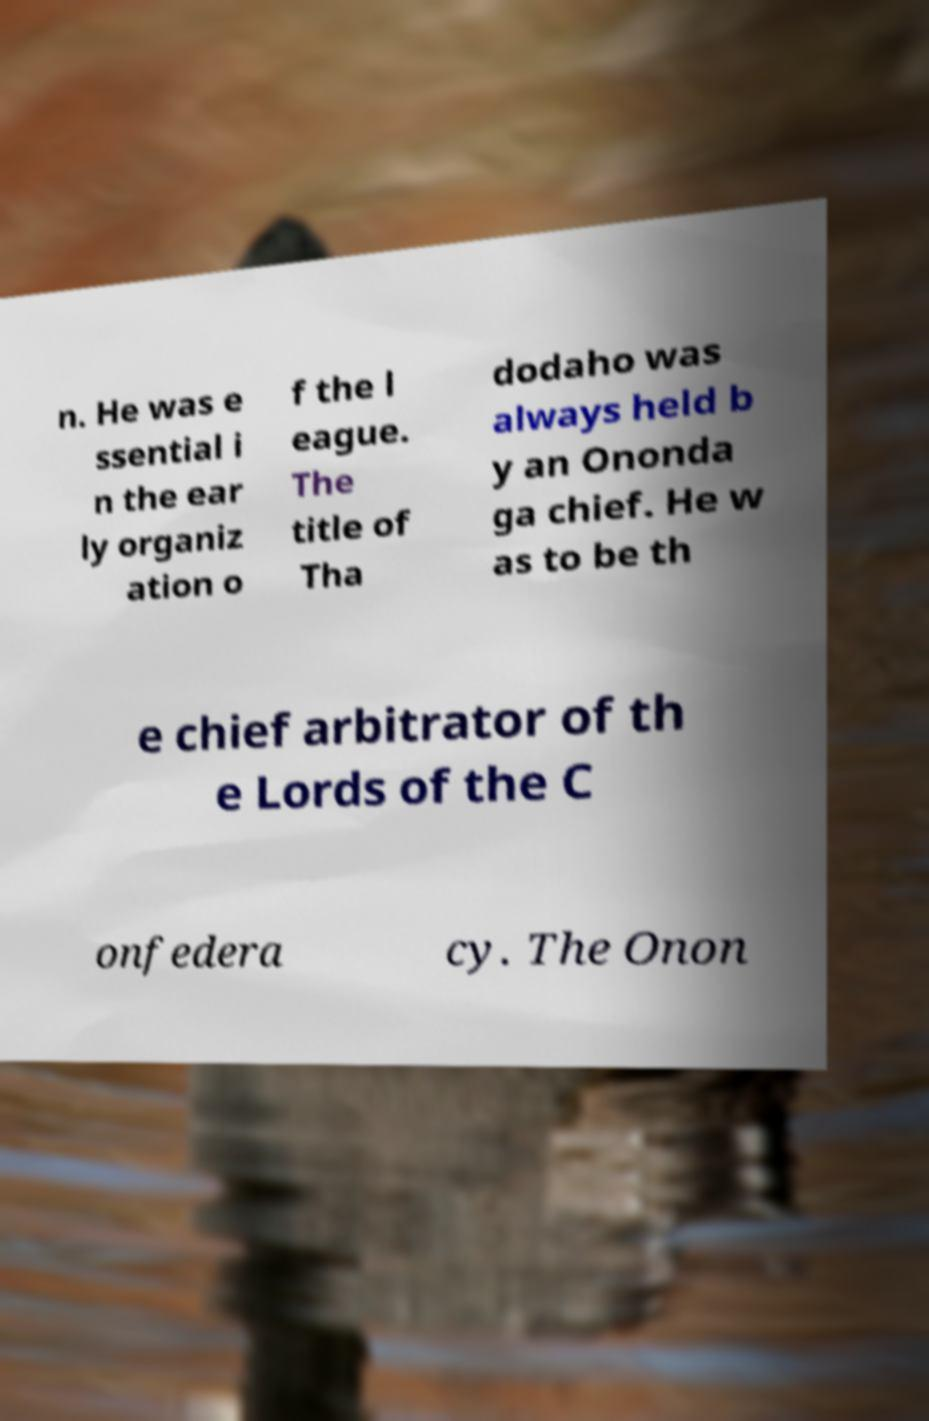For documentation purposes, I need the text within this image transcribed. Could you provide that? n. He was e ssential i n the ear ly organiz ation o f the l eague. The title of Tha dodaho was always held b y an Ononda ga chief. He w as to be th e chief arbitrator of th e Lords of the C onfedera cy. The Onon 